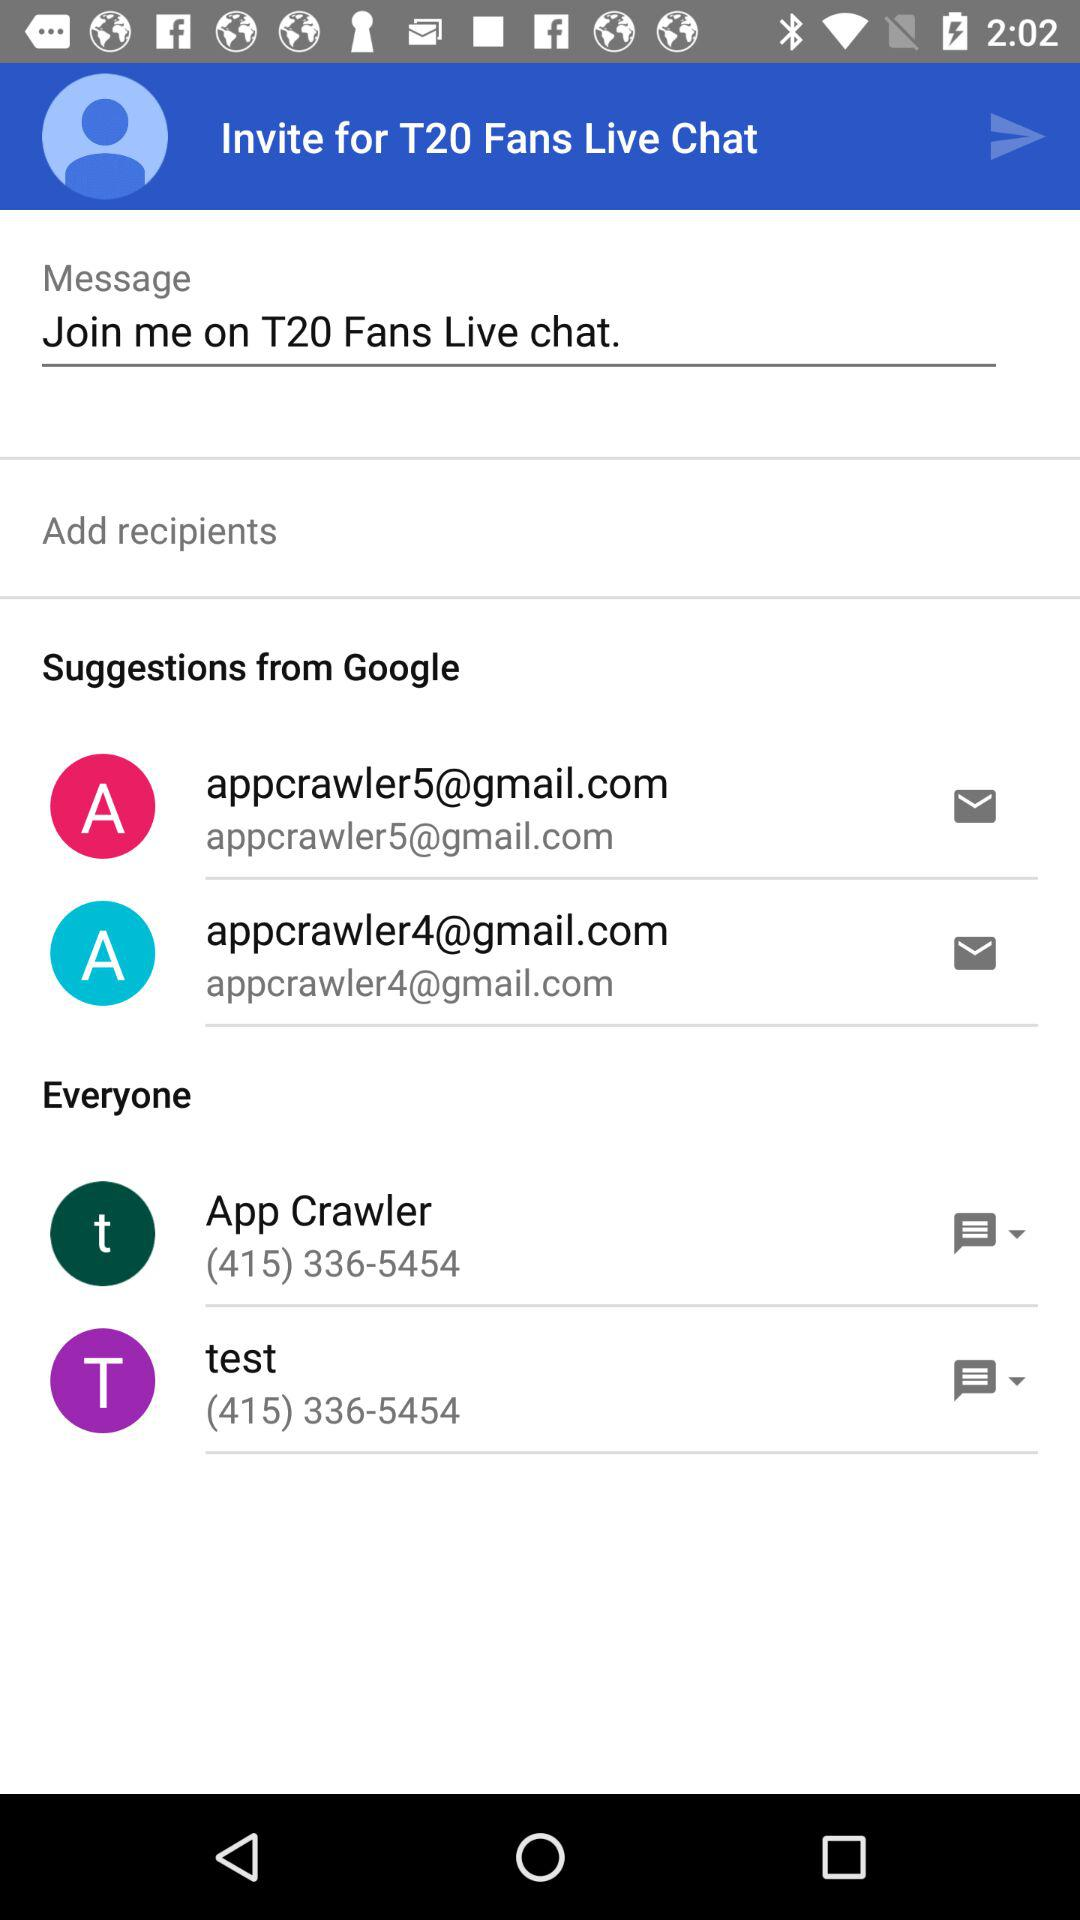What is the contact number for the App Crawler? The contact number for the App Crawler is (415) 336-5454. 